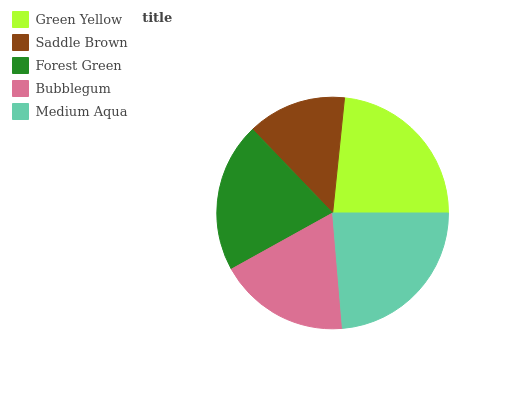Is Saddle Brown the minimum?
Answer yes or no. Yes. Is Medium Aqua the maximum?
Answer yes or no. Yes. Is Forest Green the minimum?
Answer yes or no. No. Is Forest Green the maximum?
Answer yes or no. No. Is Forest Green greater than Saddle Brown?
Answer yes or no. Yes. Is Saddle Brown less than Forest Green?
Answer yes or no. Yes. Is Saddle Brown greater than Forest Green?
Answer yes or no. No. Is Forest Green less than Saddle Brown?
Answer yes or no. No. Is Forest Green the high median?
Answer yes or no. Yes. Is Forest Green the low median?
Answer yes or no. Yes. Is Saddle Brown the high median?
Answer yes or no. No. Is Bubblegum the low median?
Answer yes or no. No. 